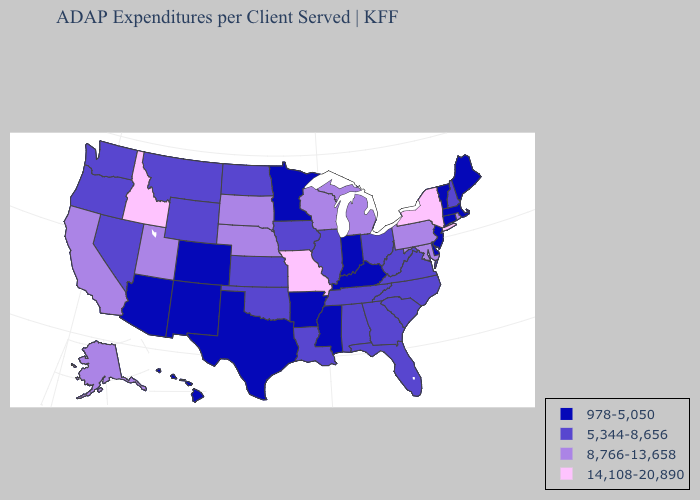Name the states that have a value in the range 978-5,050?
Keep it brief. Arizona, Arkansas, Colorado, Connecticut, Delaware, Hawaii, Indiana, Kentucky, Maine, Massachusetts, Minnesota, Mississippi, New Jersey, New Mexico, Texas, Vermont. What is the highest value in the Northeast ?
Be succinct. 14,108-20,890. Does the map have missing data?
Keep it brief. No. Name the states that have a value in the range 14,108-20,890?
Concise answer only. Idaho, Missouri, New York. What is the value of Georgia?
Keep it brief. 5,344-8,656. Among the states that border Wisconsin , which have the lowest value?
Answer briefly. Minnesota. Name the states that have a value in the range 978-5,050?
Answer briefly. Arizona, Arkansas, Colorado, Connecticut, Delaware, Hawaii, Indiana, Kentucky, Maine, Massachusetts, Minnesota, Mississippi, New Jersey, New Mexico, Texas, Vermont. Does Louisiana have the same value as Utah?
Concise answer only. No. What is the value of West Virginia?
Concise answer only. 5,344-8,656. What is the value of North Dakota?
Answer briefly. 5,344-8,656. Which states hav the highest value in the Northeast?
Short answer required. New York. What is the value of Minnesota?
Be succinct. 978-5,050. Name the states that have a value in the range 978-5,050?
Short answer required. Arizona, Arkansas, Colorado, Connecticut, Delaware, Hawaii, Indiana, Kentucky, Maine, Massachusetts, Minnesota, Mississippi, New Jersey, New Mexico, Texas, Vermont. Does Maryland have the highest value in the South?
Write a very short answer. Yes. Does Pennsylvania have a lower value than Illinois?
Answer briefly. No. 